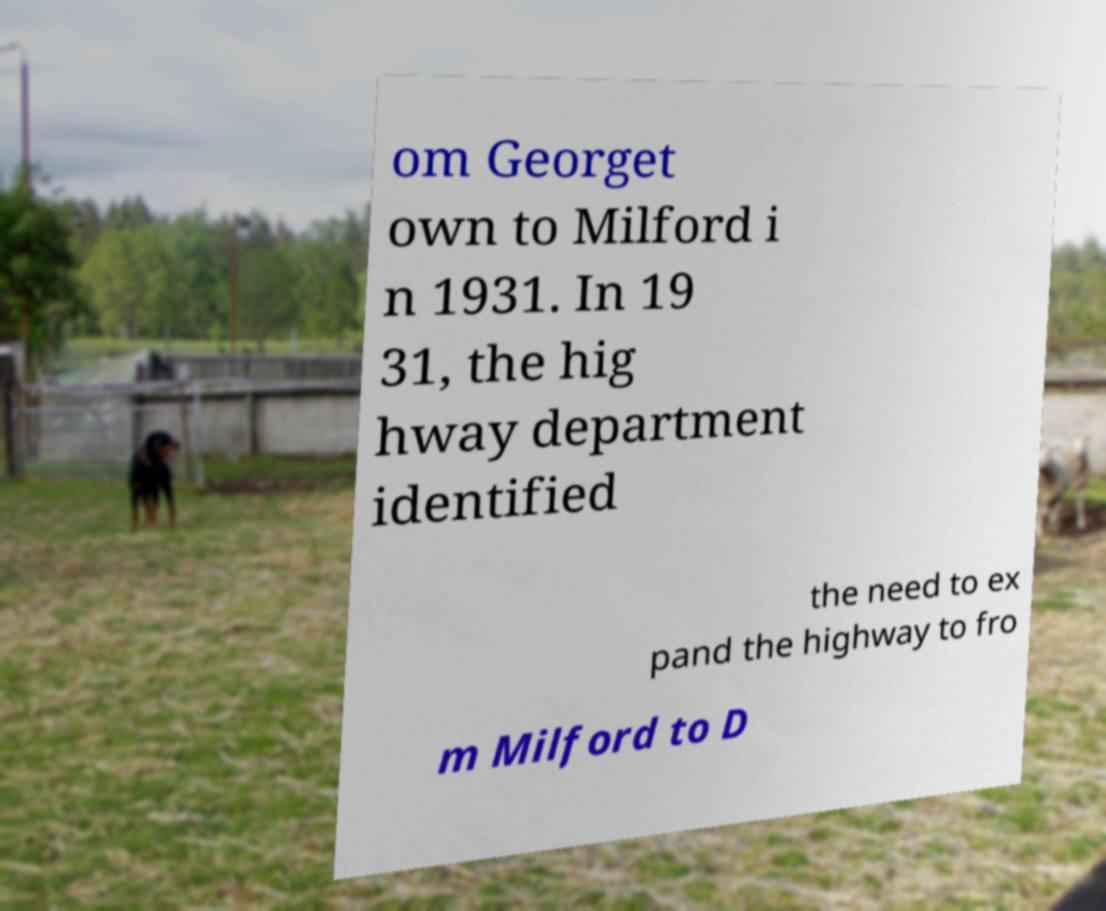Could you extract and type out the text from this image? om Georget own to Milford i n 1931. In 19 31, the hig hway department identified the need to ex pand the highway to fro m Milford to D 